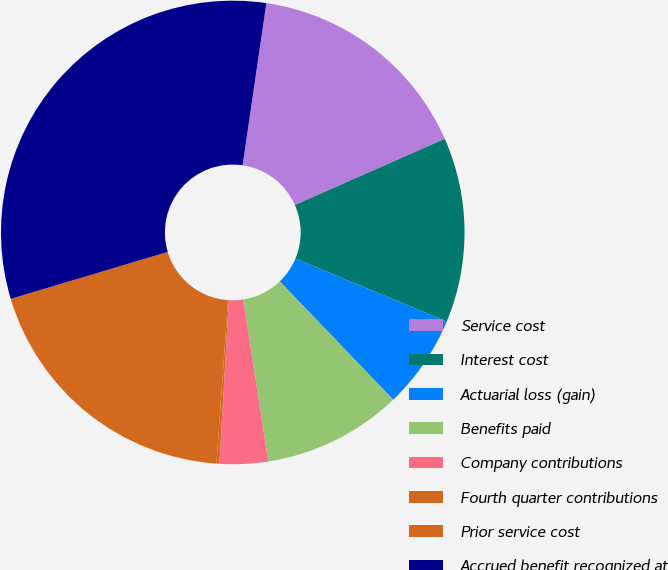Convert chart to OTSL. <chart><loc_0><loc_0><loc_500><loc_500><pie_chart><fcel>Service cost<fcel>Interest cost<fcel>Actuarial loss (gain)<fcel>Benefits paid<fcel>Company contributions<fcel>Fourth quarter contributions<fcel>Prior service cost<fcel>Accrued benefit recognized at<nl><fcel>16.07%<fcel>12.9%<fcel>6.55%<fcel>9.72%<fcel>3.37%<fcel>0.2%<fcel>19.25%<fcel>31.94%<nl></chart> 